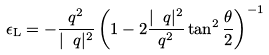<formula> <loc_0><loc_0><loc_500><loc_500>\epsilon _ { \mathrm L } = - \frac { q ^ { 2 } } { | \ q | ^ { 2 } } \left ( 1 - 2 \frac { | \ q | ^ { 2 } } { q ^ { 2 } } \tan ^ { 2 } \frac { \theta } { 2 } \right ) ^ { - 1 }</formula> 